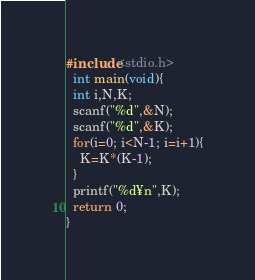Convert code to text. <code><loc_0><loc_0><loc_500><loc_500><_C_>#include<stdio.h>
  int main(void){
  int i,N,K;
  scanf("%d",&N);
  scanf("%d",&K);
  for(i=0; i<N-1; i=i+1){
    K=K*(K-1);
  }
  printf("%d¥n",K);
  return 0;
}
</code> 